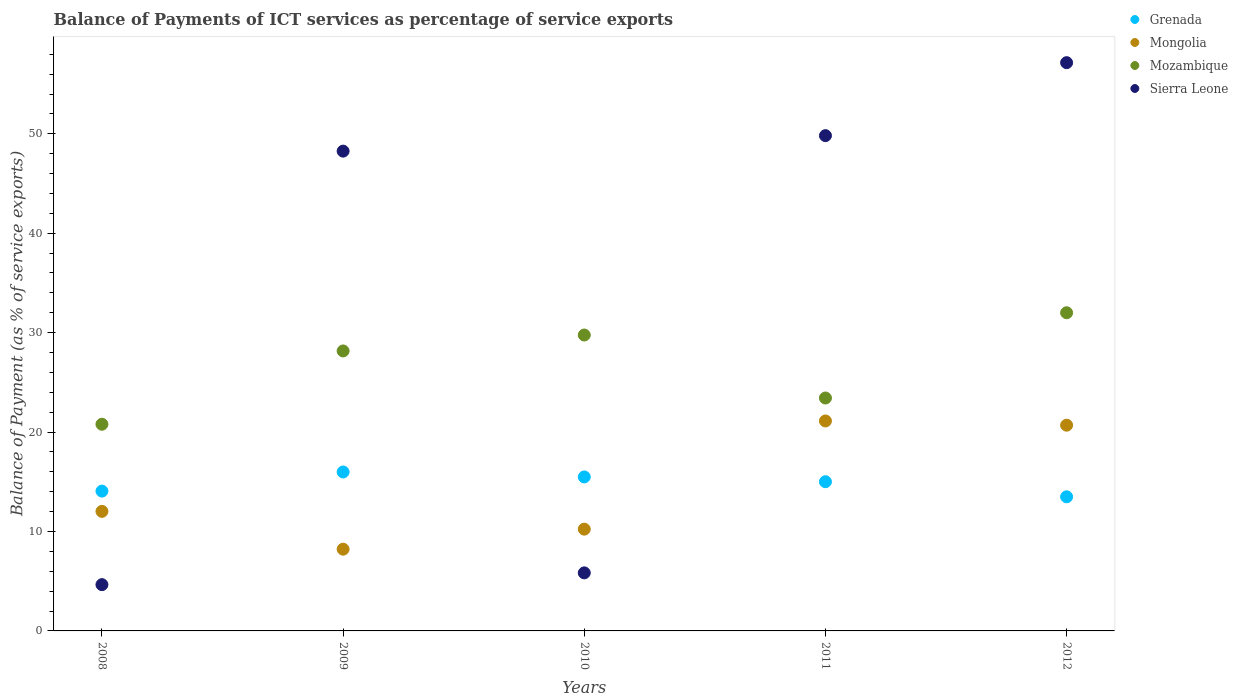Is the number of dotlines equal to the number of legend labels?
Your answer should be compact. Yes. What is the balance of payments of ICT services in Grenada in 2008?
Offer a terse response. 14.06. Across all years, what is the maximum balance of payments of ICT services in Mongolia?
Provide a succinct answer. 21.12. Across all years, what is the minimum balance of payments of ICT services in Sierra Leone?
Provide a succinct answer. 4.65. In which year was the balance of payments of ICT services in Sierra Leone maximum?
Your answer should be compact. 2012. What is the total balance of payments of ICT services in Mozambique in the graph?
Offer a terse response. 134.13. What is the difference between the balance of payments of ICT services in Mongolia in 2009 and that in 2011?
Keep it short and to the point. -12.9. What is the difference between the balance of payments of ICT services in Mongolia in 2012 and the balance of payments of ICT services in Grenada in 2008?
Make the answer very short. 6.63. What is the average balance of payments of ICT services in Sierra Leone per year?
Offer a terse response. 33.14. In the year 2009, what is the difference between the balance of payments of ICT services in Mozambique and balance of payments of ICT services in Grenada?
Provide a short and direct response. 12.17. What is the ratio of the balance of payments of ICT services in Mozambique in 2009 to that in 2012?
Your answer should be compact. 0.88. What is the difference between the highest and the second highest balance of payments of ICT services in Mongolia?
Provide a short and direct response. 0.43. What is the difference between the highest and the lowest balance of payments of ICT services in Sierra Leone?
Give a very brief answer. 52.5. Is the sum of the balance of payments of ICT services in Mozambique in 2009 and 2011 greater than the maximum balance of payments of ICT services in Grenada across all years?
Offer a very short reply. Yes. Does the balance of payments of ICT services in Grenada monotonically increase over the years?
Your response must be concise. No. Is the balance of payments of ICT services in Sierra Leone strictly less than the balance of payments of ICT services in Mongolia over the years?
Provide a succinct answer. No. How many dotlines are there?
Offer a very short reply. 4. How many years are there in the graph?
Make the answer very short. 5. What is the difference between two consecutive major ticks on the Y-axis?
Offer a very short reply. 10. Are the values on the major ticks of Y-axis written in scientific E-notation?
Your answer should be very brief. No. How many legend labels are there?
Provide a short and direct response. 4. How are the legend labels stacked?
Keep it short and to the point. Vertical. What is the title of the graph?
Your answer should be very brief. Balance of Payments of ICT services as percentage of service exports. Does "Congo (Republic)" appear as one of the legend labels in the graph?
Offer a very short reply. No. What is the label or title of the X-axis?
Keep it short and to the point. Years. What is the label or title of the Y-axis?
Your answer should be very brief. Balance of Payment (as % of service exports). What is the Balance of Payment (as % of service exports) of Grenada in 2008?
Make the answer very short. 14.06. What is the Balance of Payment (as % of service exports) of Mongolia in 2008?
Keep it short and to the point. 12.02. What is the Balance of Payment (as % of service exports) of Mozambique in 2008?
Your answer should be compact. 20.79. What is the Balance of Payment (as % of service exports) of Sierra Leone in 2008?
Offer a terse response. 4.65. What is the Balance of Payment (as % of service exports) in Grenada in 2009?
Offer a terse response. 15.99. What is the Balance of Payment (as % of service exports) of Mongolia in 2009?
Give a very brief answer. 8.22. What is the Balance of Payment (as % of service exports) of Mozambique in 2009?
Your response must be concise. 28.16. What is the Balance of Payment (as % of service exports) of Sierra Leone in 2009?
Provide a short and direct response. 48.26. What is the Balance of Payment (as % of service exports) in Grenada in 2010?
Keep it short and to the point. 15.49. What is the Balance of Payment (as % of service exports) of Mongolia in 2010?
Offer a terse response. 10.24. What is the Balance of Payment (as % of service exports) of Mozambique in 2010?
Make the answer very short. 29.76. What is the Balance of Payment (as % of service exports) of Sierra Leone in 2010?
Offer a terse response. 5.84. What is the Balance of Payment (as % of service exports) of Grenada in 2011?
Ensure brevity in your answer.  15.01. What is the Balance of Payment (as % of service exports) of Mongolia in 2011?
Offer a terse response. 21.12. What is the Balance of Payment (as % of service exports) in Mozambique in 2011?
Ensure brevity in your answer.  23.43. What is the Balance of Payment (as % of service exports) of Sierra Leone in 2011?
Give a very brief answer. 49.81. What is the Balance of Payment (as % of service exports) in Grenada in 2012?
Your response must be concise. 13.49. What is the Balance of Payment (as % of service exports) in Mongolia in 2012?
Provide a short and direct response. 20.69. What is the Balance of Payment (as % of service exports) of Mozambique in 2012?
Provide a short and direct response. 32. What is the Balance of Payment (as % of service exports) of Sierra Leone in 2012?
Make the answer very short. 57.15. Across all years, what is the maximum Balance of Payment (as % of service exports) in Grenada?
Your response must be concise. 15.99. Across all years, what is the maximum Balance of Payment (as % of service exports) of Mongolia?
Offer a very short reply. 21.12. Across all years, what is the maximum Balance of Payment (as % of service exports) in Mozambique?
Offer a terse response. 32. Across all years, what is the maximum Balance of Payment (as % of service exports) of Sierra Leone?
Ensure brevity in your answer.  57.15. Across all years, what is the minimum Balance of Payment (as % of service exports) of Grenada?
Your answer should be very brief. 13.49. Across all years, what is the minimum Balance of Payment (as % of service exports) in Mongolia?
Your answer should be very brief. 8.22. Across all years, what is the minimum Balance of Payment (as % of service exports) in Mozambique?
Provide a succinct answer. 20.79. Across all years, what is the minimum Balance of Payment (as % of service exports) of Sierra Leone?
Your response must be concise. 4.65. What is the total Balance of Payment (as % of service exports) of Grenada in the graph?
Your answer should be compact. 74.03. What is the total Balance of Payment (as % of service exports) in Mongolia in the graph?
Your response must be concise. 72.29. What is the total Balance of Payment (as % of service exports) of Mozambique in the graph?
Give a very brief answer. 134.13. What is the total Balance of Payment (as % of service exports) of Sierra Leone in the graph?
Your answer should be very brief. 165.72. What is the difference between the Balance of Payment (as % of service exports) of Grenada in 2008 and that in 2009?
Your response must be concise. -1.92. What is the difference between the Balance of Payment (as % of service exports) in Mongolia in 2008 and that in 2009?
Provide a succinct answer. 3.8. What is the difference between the Balance of Payment (as % of service exports) in Mozambique in 2008 and that in 2009?
Ensure brevity in your answer.  -7.37. What is the difference between the Balance of Payment (as % of service exports) of Sierra Leone in 2008 and that in 2009?
Keep it short and to the point. -43.6. What is the difference between the Balance of Payment (as % of service exports) of Grenada in 2008 and that in 2010?
Provide a short and direct response. -1.43. What is the difference between the Balance of Payment (as % of service exports) in Mongolia in 2008 and that in 2010?
Your response must be concise. 1.79. What is the difference between the Balance of Payment (as % of service exports) in Mozambique in 2008 and that in 2010?
Your answer should be very brief. -8.97. What is the difference between the Balance of Payment (as % of service exports) in Sierra Leone in 2008 and that in 2010?
Ensure brevity in your answer.  -1.18. What is the difference between the Balance of Payment (as % of service exports) in Grenada in 2008 and that in 2011?
Your answer should be compact. -0.94. What is the difference between the Balance of Payment (as % of service exports) in Mongolia in 2008 and that in 2011?
Your answer should be very brief. -9.09. What is the difference between the Balance of Payment (as % of service exports) in Mozambique in 2008 and that in 2011?
Your answer should be very brief. -2.64. What is the difference between the Balance of Payment (as % of service exports) in Sierra Leone in 2008 and that in 2011?
Provide a short and direct response. -45.16. What is the difference between the Balance of Payment (as % of service exports) in Grenada in 2008 and that in 2012?
Make the answer very short. 0.57. What is the difference between the Balance of Payment (as % of service exports) of Mongolia in 2008 and that in 2012?
Keep it short and to the point. -8.67. What is the difference between the Balance of Payment (as % of service exports) of Mozambique in 2008 and that in 2012?
Your response must be concise. -11.21. What is the difference between the Balance of Payment (as % of service exports) in Sierra Leone in 2008 and that in 2012?
Offer a very short reply. -52.5. What is the difference between the Balance of Payment (as % of service exports) in Grenada in 2009 and that in 2010?
Offer a very short reply. 0.5. What is the difference between the Balance of Payment (as % of service exports) in Mongolia in 2009 and that in 2010?
Provide a short and direct response. -2.02. What is the difference between the Balance of Payment (as % of service exports) of Mozambique in 2009 and that in 2010?
Provide a short and direct response. -1.6. What is the difference between the Balance of Payment (as % of service exports) of Sierra Leone in 2009 and that in 2010?
Your response must be concise. 42.42. What is the difference between the Balance of Payment (as % of service exports) in Grenada in 2009 and that in 2011?
Provide a succinct answer. 0.98. What is the difference between the Balance of Payment (as % of service exports) in Mongolia in 2009 and that in 2011?
Keep it short and to the point. -12.9. What is the difference between the Balance of Payment (as % of service exports) of Mozambique in 2009 and that in 2011?
Keep it short and to the point. 4.73. What is the difference between the Balance of Payment (as % of service exports) of Sierra Leone in 2009 and that in 2011?
Your response must be concise. -1.56. What is the difference between the Balance of Payment (as % of service exports) in Grenada in 2009 and that in 2012?
Provide a short and direct response. 2.49. What is the difference between the Balance of Payment (as % of service exports) in Mongolia in 2009 and that in 2012?
Make the answer very short. -12.47. What is the difference between the Balance of Payment (as % of service exports) in Mozambique in 2009 and that in 2012?
Your answer should be very brief. -3.84. What is the difference between the Balance of Payment (as % of service exports) of Sierra Leone in 2009 and that in 2012?
Your answer should be compact. -8.9. What is the difference between the Balance of Payment (as % of service exports) in Grenada in 2010 and that in 2011?
Offer a very short reply. 0.48. What is the difference between the Balance of Payment (as % of service exports) of Mongolia in 2010 and that in 2011?
Give a very brief answer. -10.88. What is the difference between the Balance of Payment (as % of service exports) in Mozambique in 2010 and that in 2011?
Keep it short and to the point. 6.34. What is the difference between the Balance of Payment (as % of service exports) in Sierra Leone in 2010 and that in 2011?
Ensure brevity in your answer.  -43.98. What is the difference between the Balance of Payment (as % of service exports) of Grenada in 2010 and that in 2012?
Provide a short and direct response. 2. What is the difference between the Balance of Payment (as % of service exports) in Mongolia in 2010 and that in 2012?
Provide a short and direct response. -10.46. What is the difference between the Balance of Payment (as % of service exports) of Mozambique in 2010 and that in 2012?
Offer a very short reply. -2.24. What is the difference between the Balance of Payment (as % of service exports) in Sierra Leone in 2010 and that in 2012?
Your response must be concise. -51.31. What is the difference between the Balance of Payment (as % of service exports) of Grenada in 2011 and that in 2012?
Provide a short and direct response. 1.52. What is the difference between the Balance of Payment (as % of service exports) of Mongolia in 2011 and that in 2012?
Offer a terse response. 0.43. What is the difference between the Balance of Payment (as % of service exports) in Mozambique in 2011 and that in 2012?
Provide a short and direct response. -8.58. What is the difference between the Balance of Payment (as % of service exports) of Sierra Leone in 2011 and that in 2012?
Ensure brevity in your answer.  -7.34. What is the difference between the Balance of Payment (as % of service exports) of Grenada in 2008 and the Balance of Payment (as % of service exports) of Mongolia in 2009?
Give a very brief answer. 5.84. What is the difference between the Balance of Payment (as % of service exports) in Grenada in 2008 and the Balance of Payment (as % of service exports) in Mozambique in 2009?
Provide a succinct answer. -14.1. What is the difference between the Balance of Payment (as % of service exports) in Grenada in 2008 and the Balance of Payment (as % of service exports) in Sierra Leone in 2009?
Give a very brief answer. -34.19. What is the difference between the Balance of Payment (as % of service exports) in Mongolia in 2008 and the Balance of Payment (as % of service exports) in Mozambique in 2009?
Make the answer very short. -16.14. What is the difference between the Balance of Payment (as % of service exports) of Mongolia in 2008 and the Balance of Payment (as % of service exports) of Sierra Leone in 2009?
Offer a terse response. -36.23. What is the difference between the Balance of Payment (as % of service exports) in Mozambique in 2008 and the Balance of Payment (as % of service exports) in Sierra Leone in 2009?
Make the answer very short. -27.47. What is the difference between the Balance of Payment (as % of service exports) of Grenada in 2008 and the Balance of Payment (as % of service exports) of Mongolia in 2010?
Give a very brief answer. 3.83. What is the difference between the Balance of Payment (as % of service exports) in Grenada in 2008 and the Balance of Payment (as % of service exports) in Mozambique in 2010?
Your response must be concise. -15.7. What is the difference between the Balance of Payment (as % of service exports) of Grenada in 2008 and the Balance of Payment (as % of service exports) of Sierra Leone in 2010?
Offer a very short reply. 8.22. What is the difference between the Balance of Payment (as % of service exports) in Mongolia in 2008 and the Balance of Payment (as % of service exports) in Mozambique in 2010?
Provide a succinct answer. -17.74. What is the difference between the Balance of Payment (as % of service exports) of Mongolia in 2008 and the Balance of Payment (as % of service exports) of Sierra Leone in 2010?
Give a very brief answer. 6.19. What is the difference between the Balance of Payment (as % of service exports) in Mozambique in 2008 and the Balance of Payment (as % of service exports) in Sierra Leone in 2010?
Your answer should be compact. 14.95. What is the difference between the Balance of Payment (as % of service exports) in Grenada in 2008 and the Balance of Payment (as % of service exports) in Mongolia in 2011?
Provide a succinct answer. -7.06. What is the difference between the Balance of Payment (as % of service exports) of Grenada in 2008 and the Balance of Payment (as % of service exports) of Mozambique in 2011?
Keep it short and to the point. -9.36. What is the difference between the Balance of Payment (as % of service exports) of Grenada in 2008 and the Balance of Payment (as % of service exports) of Sierra Leone in 2011?
Your answer should be very brief. -35.75. What is the difference between the Balance of Payment (as % of service exports) of Mongolia in 2008 and the Balance of Payment (as % of service exports) of Mozambique in 2011?
Offer a very short reply. -11.4. What is the difference between the Balance of Payment (as % of service exports) of Mongolia in 2008 and the Balance of Payment (as % of service exports) of Sierra Leone in 2011?
Give a very brief answer. -37.79. What is the difference between the Balance of Payment (as % of service exports) of Mozambique in 2008 and the Balance of Payment (as % of service exports) of Sierra Leone in 2011?
Your answer should be compact. -29.03. What is the difference between the Balance of Payment (as % of service exports) of Grenada in 2008 and the Balance of Payment (as % of service exports) of Mongolia in 2012?
Offer a terse response. -6.63. What is the difference between the Balance of Payment (as % of service exports) in Grenada in 2008 and the Balance of Payment (as % of service exports) in Mozambique in 2012?
Provide a succinct answer. -17.94. What is the difference between the Balance of Payment (as % of service exports) of Grenada in 2008 and the Balance of Payment (as % of service exports) of Sierra Leone in 2012?
Provide a succinct answer. -43.09. What is the difference between the Balance of Payment (as % of service exports) of Mongolia in 2008 and the Balance of Payment (as % of service exports) of Mozambique in 2012?
Your answer should be compact. -19.98. What is the difference between the Balance of Payment (as % of service exports) of Mongolia in 2008 and the Balance of Payment (as % of service exports) of Sierra Leone in 2012?
Your response must be concise. -45.13. What is the difference between the Balance of Payment (as % of service exports) of Mozambique in 2008 and the Balance of Payment (as % of service exports) of Sierra Leone in 2012?
Give a very brief answer. -36.37. What is the difference between the Balance of Payment (as % of service exports) in Grenada in 2009 and the Balance of Payment (as % of service exports) in Mongolia in 2010?
Provide a succinct answer. 5.75. What is the difference between the Balance of Payment (as % of service exports) of Grenada in 2009 and the Balance of Payment (as % of service exports) of Mozambique in 2010?
Your answer should be very brief. -13.78. What is the difference between the Balance of Payment (as % of service exports) in Grenada in 2009 and the Balance of Payment (as % of service exports) in Sierra Leone in 2010?
Provide a short and direct response. 10.15. What is the difference between the Balance of Payment (as % of service exports) of Mongolia in 2009 and the Balance of Payment (as % of service exports) of Mozambique in 2010?
Offer a very short reply. -21.54. What is the difference between the Balance of Payment (as % of service exports) of Mongolia in 2009 and the Balance of Payment (as % of service exports) of Sierra Leone in 2010?
Give a very brief answer. 2.38. What is the difference between the Balance of Payment (as % of service exports) in Mozambique in 2009 and the Balance of Payment (as % of service exports) in Sierra Leone in 2010?
Ensure brevity in your answer.  22.32. What is the difference between the Balance of Payment (as % of service exports) in Grenada in 2009 and the Balance of Payment (as % of service exports) in Mongolia in 2011?
Your answer should be compact. -5.13. What is the difference between the Balance of Payment (as % of service exports) of Grenada in 2009 and the Balance of Payment (as % of service exports) of Mozambique in 2011?
Ensure brevity in your answer.  -7.44. What is the difference between the Balance of Payment (as % of service exports) of Grenada in 2009 and the Balance of Payment (as % of service exports) of Sierra Leone in 2011?
Give a very brief answer. -33.83. What is the difference between the Balance of Payment (as % of service exports) of Mongolia in 2009 and the Balance of Payment (as % of service exports) of Mozambique in 2011?
Your answer should be compact. -15.2. What is the difference between the Balance of Payment (as % of service exports) of Mongolia in 2009 and the Balance of Payment (as % of service exports) of Sierra Leone in 2011?
Make the answer very short. -41.59. What is the difference between the Balance of Payment (as % of service exports) in Mozambique in 2009 and the Balance of Payment (as % of service exports) in Sierra Leone in 2011?
Your answer should be very brief. -21.65. What is the difference between the Balance of Payment (as % of service exports) in Grenada in 2009 and the Balance of Payment (as % of service exports) in Mongolia in 2012?
Give a very brief answer. -4.71. What is the difference between the Balance of Payment (as % of service exports) of Grenada in 2009 and the Balance of Payment (as % of service exports) of Mozambique in 2012?
Your response must be concise. -16.02. What is the difference between the Balance of Payment (as % of service exports) in Grenada in 2009 and the Balance of Payment (as % of service exports) in Sierra Leone in 2012?
Provide a succinct answer. -41.17. What is the difference between the Balance of Payment (as % of service exports) of Mongolia in 2009 and the Balance of Payment (as % of service exports) of Mozambique in 2012?
Provide a succinct answer. -23.78. What is the difference between the Balance of Payment (as % of service exports) of Mongolia in 2009 and the Balance of Payment (as % of service exports) of Sierra Leone in 2012?
Your answer should be compact. -48.93. What is the difference between the Balance of Payment (as % of service exports) of Mozambique in 2009 and the Balance of Payment (as % of service exports) of Sierra Leone in 2012?
Your response must be concise. -28.99. What is the difference between the Balance of Payment (as % of service exports) in Grenada in 2010 and the Balance of Payment (as % of service exports) in Mongolia in 2011?
Make the answer very short. -5.63. What is the difference between the Balance of Payment (as % of service exports) of Grenada in 2010 and the Balance of Payment (as % of service exports) of Mozambique in 2011?
Keep it short and to the point. -7.94. What is the difference between the Balance of Payment (as % of service exports) of Grenada in 2010 and the Balance of Payment (as % of service exports) of Sierra Leone in 2011?
Keep it short and to the point. -34.33. What is the difference between the Balance of Payment (as % of service exports) in Mongolia in 2010 and the Balance of Payment (as % of service exports) in Mozambique in 2011?
Provide a succinct answer. -13.19. What is the difference between the Balance of Payment (as % of service exports) of Mongolia in 2010 and the Balance of Payment (as % of service exports) of Sierra Leone in 2011?
Your response must be concise. -39.58. What is the difference between the Balance of Payment (as % of service exports) of Mozambique in 2010 and the Balance of Payment (as % of service exports) of Sierra Leone in 2011?
Your answer should be very brief. -20.05. What is the difference between the Balance of Payment (as % of service exports) in Grenada in 2010 and the Balance of Payment (as % of service exports) in Mongolia in 2012?
Ensure brevity in your answer.  -5.2. What is the difference between the Balance of Payment (as % of service exports) of Grenada in 2010 and the Balance of Payment (as % of service exports) of Mozambique in 2012?
Your response must be concise. -16.51. What is the difference between the Balance of Payment (as % of service exports) in Grenada in 2010 and the Balance of Payment (as % of service exports) in Sierra Leone in 2012?
Provide a short and direct response. -41.66. What is the difference between the Balance of Payment (as % of service exports) in Mongolia in 2010 and the Balance of Payment (as % of service exports) in Mozambique in 2012?
Offer a very short reply. -21.76. What is the difference between the Balance of Payment (as % of service exports) of Mongolia in 2010 and the Balance of Payment (as % of service exports) of Sierra Leone in 2012?
Provide a short and direct response. -46.92. What is the difference between the Balance of Payment (as % of service exports) in Mozambique in 2010 and the Balance of Payment (as % of service exports) in Sierra Leone in 2012?
Keep it short and to the point. -27.39. What is the difference between the Balance of Payment (as % of service exports) in Grenada in 2011 and the Balance of Payment (as % of service exports) in Mongolia in 2012?
Offer a terse response. -5.69. What is the difference between the Balance of Payment (as % of service exports) in Grenada in 2011 and the Balance of Payment (as % of service exports) in Mozambique in 2012?
Your response must be concise. -16.99. What is the difference between the Balance of Payment (as % of service exports) in Grenada in 2011 and the Balance of Payment (as % of service exports) in Sierra Leone in 2012?
Provide a succinct answer. -42.15. What is the difference between the Balance of Payment (as % of service exports) in Mongolia in 2011 and the Balance of Payment (as % of service exports) in Mozambique in 2012?
Your answer should be very brief. -10.88. What is the difference between the Balance of Payment (as % of service exports) of Mongolia in 2011 and the Balance of Payment (as % of service exports) of Sierra Leone in 2012?
Your answer should be very brief. -36.04. What is the difference between the Balance of Payment (as % of service exports) of Mozambique in 2011 and the Balance of Payment (as % of service exports) of Sierra Leone in 2012?
Ensure brevity in your answer.  -33.73. What is the average Balance of Payment (as % of service exports) in Grenada per year?
Offer a very short reply. 14.81. What is the average Balance of Payment (as % of service exports) in Mongolia per year?
Provide a short and direct response. 14.46. What is the average Balance of Payment (as % of service exports) in Mozambique per year?
Provide a succinct answer. 26.83. What is the average Balance of Payment (as % of service exports) of Sierra Leone per year?
Offer a very short reply. 33.14. In the year 2008, what is the difference between the Balance of Payment (as % of service exports) in Grenada and Balance of Payment (as % of service exports) in Mongolia?
Provide a succinct answer. 2.04. In the year 2008, what is the difference between the Balance of Payment (as % of service exports) in Grenada and Balance of Payment (as % of service exports) in Mozambique?
Offer a very short reply. -6.72. In the year 2008, what is the difference between the Balance of Payment (as % of service exports) of Grenada and Balance of Payment (as % of service exports) of Sierra Leone?
Keep it short and to the point. 9.41. In the year 2008, what is the difference between the Balance of Payment (as % of service exports) of Mongolia and Balance of Payment (as % of service exports) of Mozambique?
Provide a succinct answer. -8.76. In the year 2008, what is the difference between the Balance of Payment (as % of service exports) in Mongolia and Balance of Payment (as % of service exports) in Sierra Leone?
Make the answer very short. 7.37. In the year 2008, what is the difference between the Balance of Payment (as % of service exports) of Mozambique and Balance of Payment (as % of service exports) of Sierra Leone?
Your answer should be compact. 16.13. In the year 2009, what is the difference between the Balance of Payment (as % of service exports) of Grenada and Balance of Payment (as % of service exports) of Mongolia?
Your response must be concise. 7.76. In the year 2009, what is the difference between the Balance of Payment (as % of service exports) of Grenada and Balance of Payment (as % of service exports) of Mozambique?
Keep it short and to the point. -12.17. In the year 2009, what is the difference between the Balance of Payment (as % of service exports) of Grenada and Balance of Payment (as % of service exports) of Sierra Leone?
Offer a very short reply. -32.27. In the year 2009, what is the difference between the Balance of Payment (as % of service exports) in Mongolia and Balance of Payment (as % of service exports) in Mozambique?
Provide a short and direct response. -19.94. In the year 2009, what is the difference between the Balance of Payment (as % of service exports) of Mongolia and Balance of Payment (as % of service exports) of Sierra Leone?
Make the answer very short. -40.03. In the year 2009, what is the difference between the Balance of Payment (as % of service exports) of Mozambique and Balance of Payment (as % of service exports) of Sierra Leone?
Your response must be concise. -20.1. In the year 2010, what is the difference between the Balance of Payment (as % of service exports) of Grenada and Balance of Payment (as % of service exports) of Mongolia?
Ensure brevity in your answer.  5.25. In the year 2010, what is the difference between the Balance of Payment (as % of service exports) of Grenada and Balance of Payment (as % of service exports) of Mozambique?
Provide a short and direct response. -14.27. In the year 2010, what is the difference between the Balance of Payment (as % of service exports) of Grenada and Balance of Payment (as % of service exports) of Sierra Leone?
Give a very brief answer. 9.65. In the year 2010, what is the difference between the Balance of Payment (as % of service exports) of Mongolia and Balance of Payment (as % of service exports) of Mozambique?
Ensure brevity in your answer.  -19.52. In the year 2010, what is the difference between the Balance of Payment (as % of service exports) in Mongolia and Balance of Payment (as % of service exports) in Sierra Leone?
Provide a succinct answer. 4.4. In the year 2010, what is the difference between the Balance of Payment (as % of service exports) in Mozambique and Balance of Payment (as % of service exports) in Sierra Leone?
Your answer should be compact. 23.92. In the year 2011, what is the difference between the Balance of Payment (as % of service exports) in Grenada and Balance of Payment (as % of service exports) in Mongolia?
Your answer should be compact. -6.11. In the year 2011, what is the difference between the Balance of Payment (as % of service exports) of Grenada and Balance of Payment (as % of service exports) of Mozambique?
Provide a succinct answer. -8.42. In the year 2011, what is the difference between the Balance of Payment (as % of service exports) in Grenada and Balance of Payment (as % of service exports) in Sierra Leone?
Provide a succinct answer. -34.81. In the year 2011, what is the difference between the Balance of Payment (as % of service exports) of Mongolia and Balance of Payment (as % of service exports) of Mozambique?
Ensure brevity in your answer.  -2.31. In the year 2011, what is the difference between the Balance of Payment (as % of service exports) of Mongolia and Balance of Payment (as % of service exports) of Sierra Leone?
Keep it short and to the point. -28.7. In the year 2011, what is the difference between the Balance of Payment (as % of service exports) in Mozambique and Balance of Payment (as % of service exports) in Sierra Leone?
Offer a very short reply. -26.39. In the year 2012, what is the difference between the Balance of Payment (as % of service exports) of Grenada and Balance of Payment (as % of service exports) of Mongolia?
Your response must be concise. -7.2. In the year 2012, what is the difference between the Balance of Payment (as % of service exports) of Grenada and Balance of Payment (as % of service exports) of Mozambique?
Offer a terse response. -18.51. In the year 2012, what is the difference between the Balance of Payment (as % of service exports) of Grenada and Balance of Payment (as % of service exports) of Sierra Leone?
Your response must be concise. -43.66. In the year 2012, what is the difference between the Balance of Payment (as % of service exports) of Mongolia and Balance of Payment (as % of service exports) of Mozambique?
Your response must be concise. -11.31. In the year 2012, what is the difference between the Balance of Payment (as % of service exports) of Mongolia and Balance of Payment (as % of service exports) of Sierra Leone?
Your response must be concise. -36.46. In the year 2012, what is the difference between the Balance of Payment (as % of service exports) of Mozambique and Balance of Payment (as % of service exports) of Sierra Leone?
Provide a succinct answer. -25.15. What is the ratio of the Balance of Payment (as % of service exports) of Grenada in 2008 to that in 2009?
Provide a short and direct response. 0.88. What is the ratio of the Balance of Payment (as % of service exports) in Mongolia in 2008 to that in 2009?
Make the answer very short. 1.46. What is the ratio of the Balance of Payment (as % of service exports) in Mozambique in 2008 to that in 2009?
Give a very brief answer. 0.74. What is the ratio of the Balance of Payment (as % of service exports) of Sierra Leone in 2008 to that in 2009?
Offer a terse response. 0.1. What is the ratio of the Balance of Payment (as % of service exports) of Grenada in 2008 to that in 2010?
Keep it short and to the point. 0.91. What is the ratio of the Balance of Payment (as % of service exports) of Mongolia in 2008 to that in 2010?
Your answer should be compact. 1.17. What is the ratio of the Balance of Payment (as % of service exports) in Mozambique in 2008 to that in 2010?
Make the answer very short. 0.7. What is the ratio of the Balance of Payment (as % of service exports) of Sierra Leone in 2008 to that in 2010?
Your answer should be compact. 0.8. What is the ratio of the Balance of Payment (as % of service exports) in Grenada in 2008 to that in 2011?
Your answer should be compact. 0.94. What is the ratio of the Balance of Payment (as % of service exports) in Mongolia in 2008 to that in 2011?
Give a very brief answer. 0.57. What is the ratio of the Balance of Payment (as % of service exports) of Mozambique in 2008 to that in 2011?
Your answer should be compact. 0.89. What is the ratio of the Balance of Payment (as % of service exports) in Sierra Leone in 2008 to that in 2011?
Keep it short and to the point. 0.09. What is the ratio of the Balance of Payment (as % of service exports) in Grenada in 2008 to that in 2012?
Make the answer very short. 1.04. What is the ratio of the Balance of Payment (as % of service exports) in Mongolia in 2008 to that in 2012?
Offer a terse response. 0.58. What is the ratio of the Balance of Payment (as % of service exports) in Mozambique in 2008 to that in 2012?
Keep it short and to the point. 0.65. What is the ratio of the Balance of Payment (as % of service exports) of Sierra Leone in 2008 to that in 2012?
Ensure brevity in your answer.  0.08. What is the ratio of the Balance of Payment (as % of service exports) in Grenada in 2009 to that in 2010?
Give a very brief answer. 1.03. What is the ratio of the Balance of Payment (as % of service exports) in Mongolia in 2009 to that in 2010?
Make the answer very short. 0.8. What is the ratio of the Balance of Payment (as % of service exports) of Mozambique in 2009 to that in 2010?
Keep it short and to the point. 0.95. What is the ratio of the Balance of Payment (as % of service exports) in Sierra Leone in 2009 to that in 2010?
Your response must be concise. 8.27. What is the ratio of the Balance of Payment (as % of service exports) of Grenada in 2009 to that in 2011?
Your answer should be very brief. 1.07. What is the ratio of the Balance of Payment (as % of service exports) of Mongolia in 2009 to that in 2011?
Give a very brief answer. 0.39. What is the ratio of the Balance of Payment (as % of service exports) in Mozambique in 2009 to that in 2011?
Offer a very short reply. 1.2. What is the ratio of the Balance of Payment (as % of service exports) in Sierra Leone in 2009 to that in 2011?
Provide a short and direct response. 0.97. What is the ratio of the Balance of Payment (as % of service exports) of Grenada in 2009 to that in 2012?
Offer a very short reply. 1.18. What is the ratio of the Balance of Payment (as % of service exports) of Mongolia in 2009 to that in 2012?
Your answer should be compact. 0.4. What is the ratio of the Balance of Payment (as % of service exports) of Sierra Leone in 2009 to that in 2012?
Your response must be concise. 0.84. What is the ratio of the Balance of Payment (as % of service exports) in Grenada in 2010 to that in 2011?
Your answer should be very brief. 1.03. What is the ratio of the Balance of Payment (as % of service exports) of Mongolia in 2010 to that in 2011?
Keep it short and to the point. 0.48. What is the ratio of the Balance of Payment (as % of service exports) in Mozambique in 2010 to that in 2011?
Your response must be concise. 1.27. What is the ratio of the Balance of Payment (as % of service exports) of Sierra Leone in 2010 to that in 2011?
Your answer should be compact. 0.12. What is the ratio of the Balance of Payment (as % of service exports) of Grenada in 2010 to that in 2012?
Give a very brief answer. 1.15. What is the ratio of the Balance of Payment (as % of service exports) in Mongolia in 2010 to that in 2012?
Your response must be concise. 0.49. What is the ratio of the Balance of Payment (as % of service exports) in Sierra Leone in 2010 to that in 2012?
Make the answer very short. 0.1. What is the ratio of the Balance of Payment (as % of service exports) in Grenada in 2011 to that in 2012?
Provide a short and direct response. 1.11. What is the ratio of the Balance of Payment (as % of service exports) in Mongolia in 2011 to that in 2012?
Provide a short and direct response. 1.02. What is the ratio of the Balance of Payment (as % of service exports) of Mozambique in 2011 to that in 2012?
Give a very brief answer. 0.73. What is the ratio of the Balance of Payment (as % of service exports) of Sierra Leone in 2011 to that in 2012?
Offer a terse response. 0.87. What is the difference between the highest and the second highest Balance of Payment (as % of service exports) of Grenada?
Provide a succinct answer. 0.5. What is the difference between the highest and the second highest Balance of Payment (as % of service exports) of Mongolia?
Offer a very short reply. 0.43. What is the difference between the highest and the second highest Balance of Payment (as % of service exports) in Mozambique?
Offer a terse response. 2.24. What is the difference between the highest and the second highest Balance of Payment (as % of service exports) in Sierra Leone?
Offer a terse response. 7.34. What is the difference between the highest and the lowest Balance of Payment (as % of service exports) of Grenada?
Your answer should be very brief. 2.49. What is the difference between the highest and the lowest Balance of Payment (as % of service exports) of Mongolia?
Offer a terse response. 12.9. What is the difference between the highest and the lowest Balance of Payment (as % of service exports) in Mozambique?
Give a very brief answer. 11.21. What is the difference between the highest and the lowest Balance of Payment (as % of service exports) in Sierra Leone?
Offer a terse response. 52.5. 